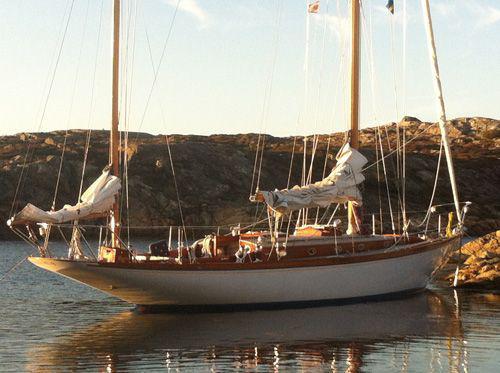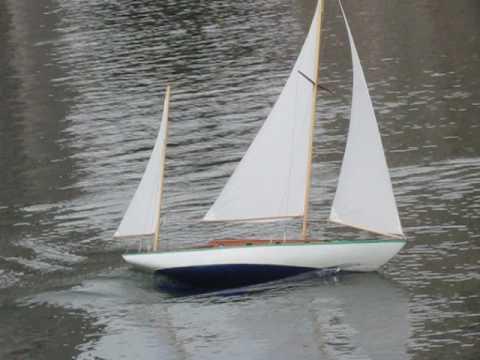The first image is the image on the left, the second image is the image on the right. Analyze the images presented: Is the assertion "An image shows at least one undocked boat surrounded by water." valid? Answer yes or no. Yes. The first image is the image on the left, the second image is the image on the right. Given the left and right images, does the statement "The right image shows a model ship on a wooden plaque." hold true? Answer yes or no. No. 